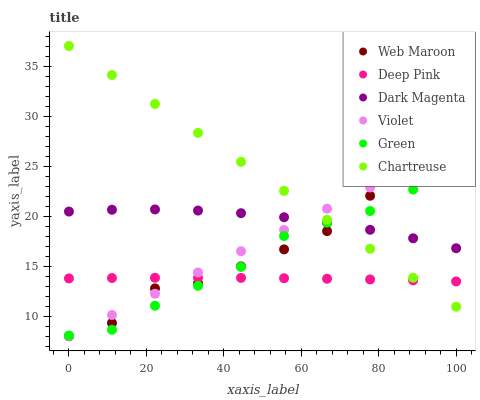Does Deep Pink have the minimum area under the curve?
Answer yes or no. Yes. Does Chartreuse have the maximum area under the curve?
Answer yes or no. Yes. Does Dark Magenta have the minimum area under the curve?
Answer yes or no. No. Does Dark Magenta have the maximum area under the curve?
Answer yes or no. No. Is Violet the smoothest?
Answer yes or no. Yes. Is Web Maroon the roughest?
Answer yes or no. Yes. Is Dark Magenta the smoothest?
Answer yes or no. No. Is Dark Magenta the roughest?
Answer yes or no. No. Does Web Maroon have the lowest value?
Answer yes or no. Yes. Does Dark Magenta have the lowest value?
Answer yes or no. No. Does Chartreuse have the highest value?
Answer yes or no. Yes. Does Dark Magenta have the highest value?
Answer yes or no. No. Is Deep Pink less than Dark Magenta?
Answer yes or no. Yes. Is Dark Magenta greater than Deep Pink?
Answer yes or no. Yes. Does Violet intersect Chartreuse?
Answer yes or no. Yes. Is Violet less than Chartreuse?
Answer yes or no. No. Is Violet greater than Chartreuse?
Answer yes or no. No. Does Deep Pink intersect Dark Magenta?
Answer yes or no. No. 